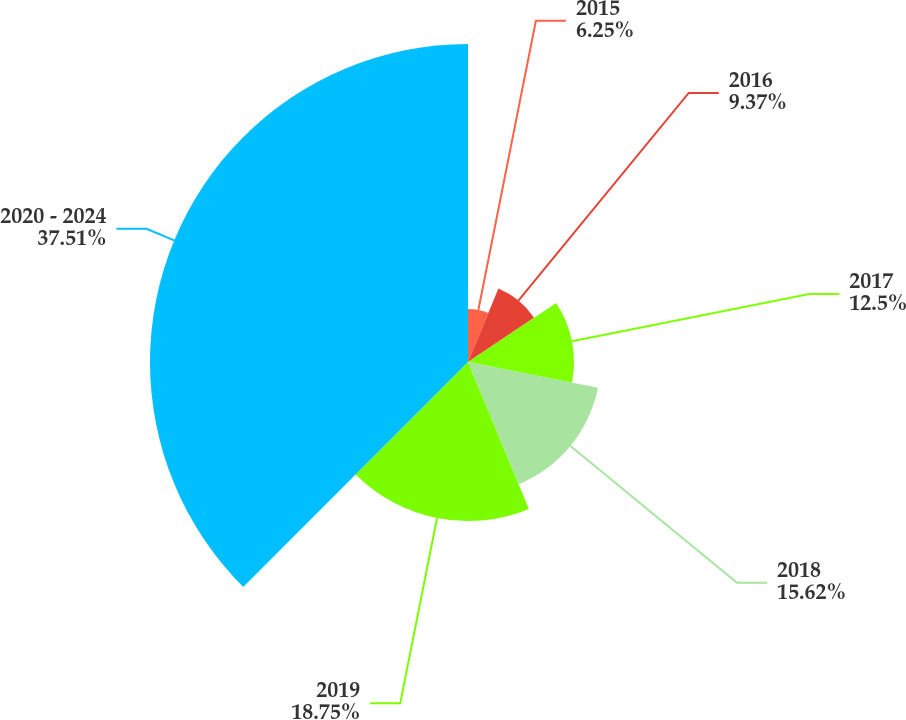Convert chart. <chart><loc_0><loc_0><loc_500><loc_500><pie_chart><fcel>2015<fcel>2016<fcel>2017<fcel>2018<fcel>2019<fcel>2020 - 2024<nl><fcel>6.25%<fcel>9.37%<fcel>12.5%<fcel>15.62%<fcel>18.75%<fcel>37.5%<nl></chart> 